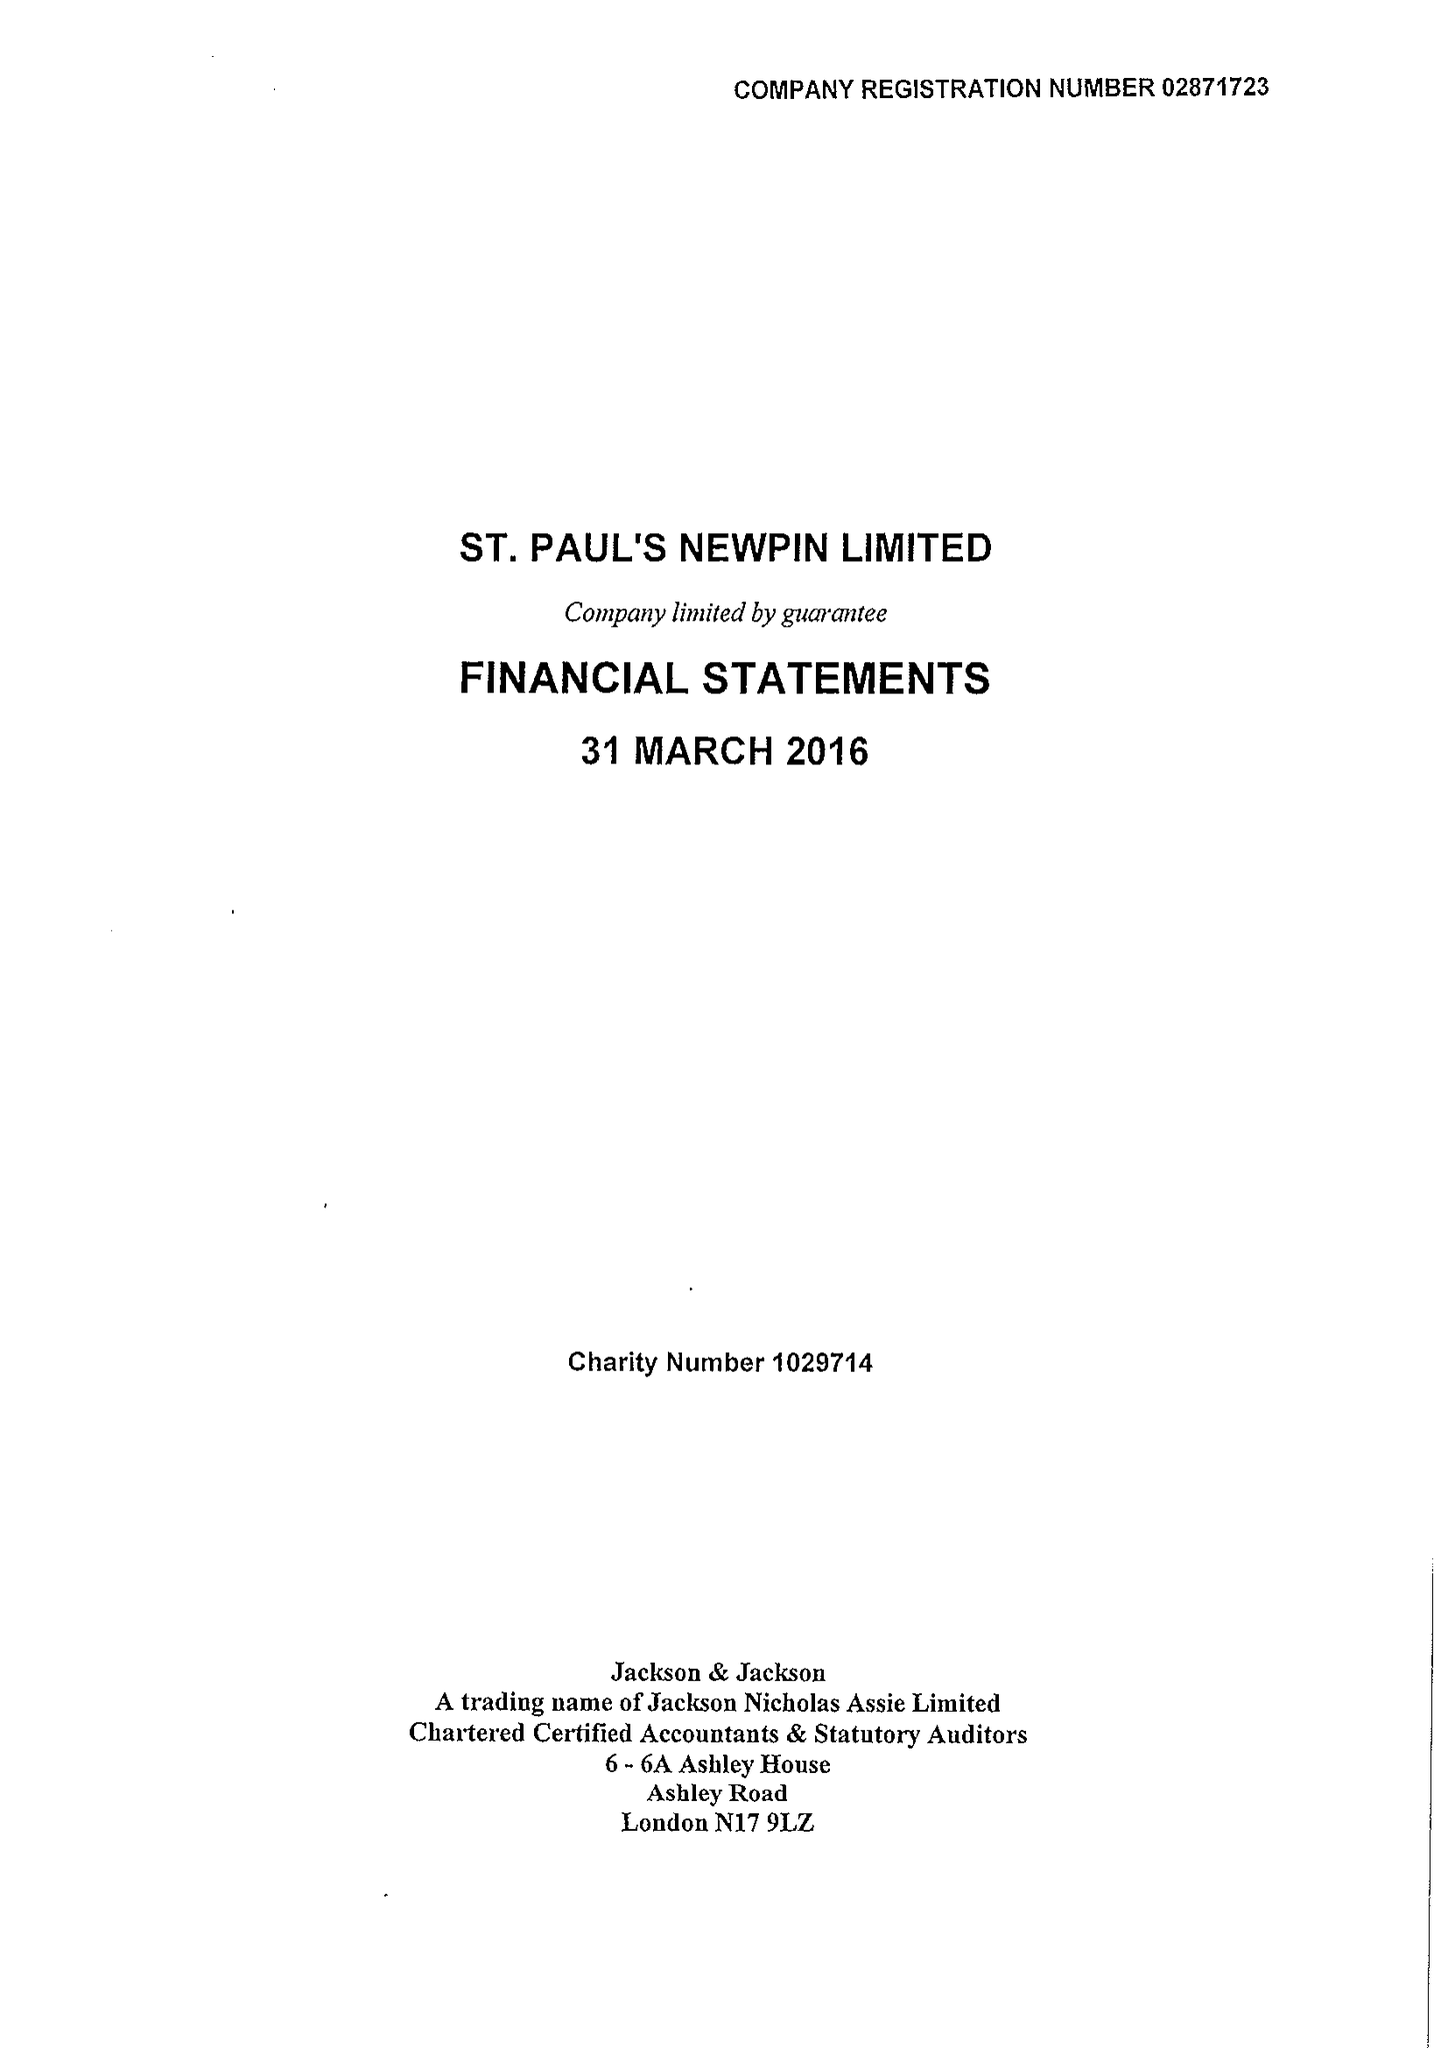What is the value for the income_annually_in_british_pounds?
Answer the question using a single word or phrase. 115501.00 